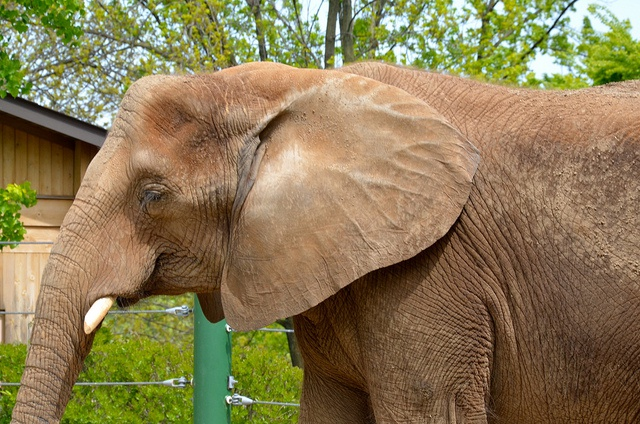Describe the objects in this image and their specific colors. I can see a elephant in olive, tan, gray, and maroon tones in this image. 